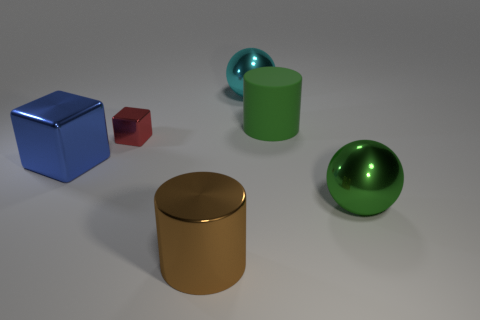Add 2 green cylinders. How many objects exist? 8 Subtract all blocks. How many objects are left? 4 Subtract 0 cyan blocks. How many objects are left? 6 Subtract all large purple things. Subtract all red blocks. How many objects are left? 5 Add 2 blue cubes. How many blue cubes are left? 3 Add 3 big cyan things. How many big cyan things exist? 4 